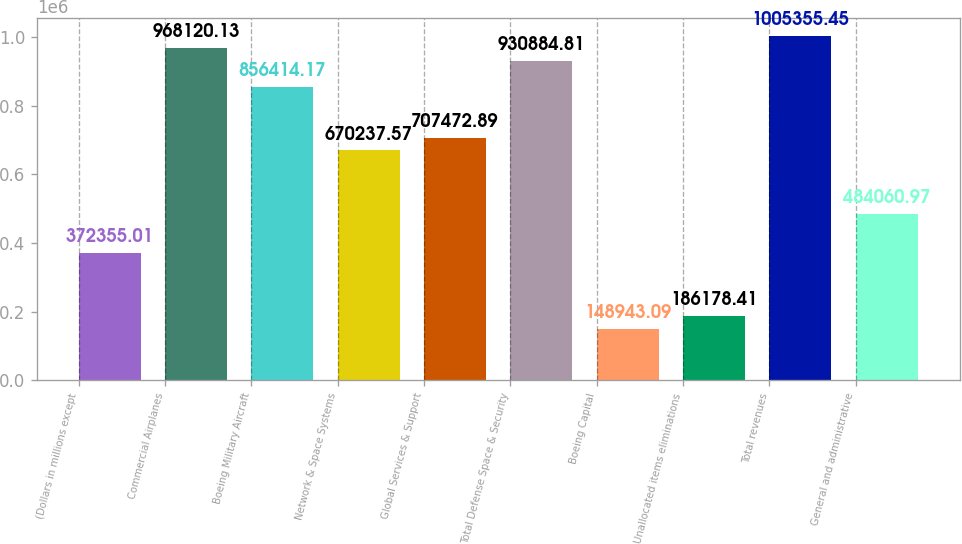Convert chart. <chart><loc_0><loc_0><loc_500><loc_500><bar_chart><fcel>(Dollars in millions except<fcel>Commercial Airplanes<fcel>Boeing Military Aircraft<fcel>Network & Space Systems<fcel>Global Services & Support<fcel>Total Defense Space & Security<fcel>Boeing Capital<fcel>Unallocated items eliminations<fcel>Total revenues<fcel>General and administrative<nl><fcel>372355<fcel>968120<fcel>856414<fcel>670238<fcel>707473<fcel>930885<fcel>148943<fcel>186178<fcel>1.00536e+06<fcel>484061<nl></chart> 